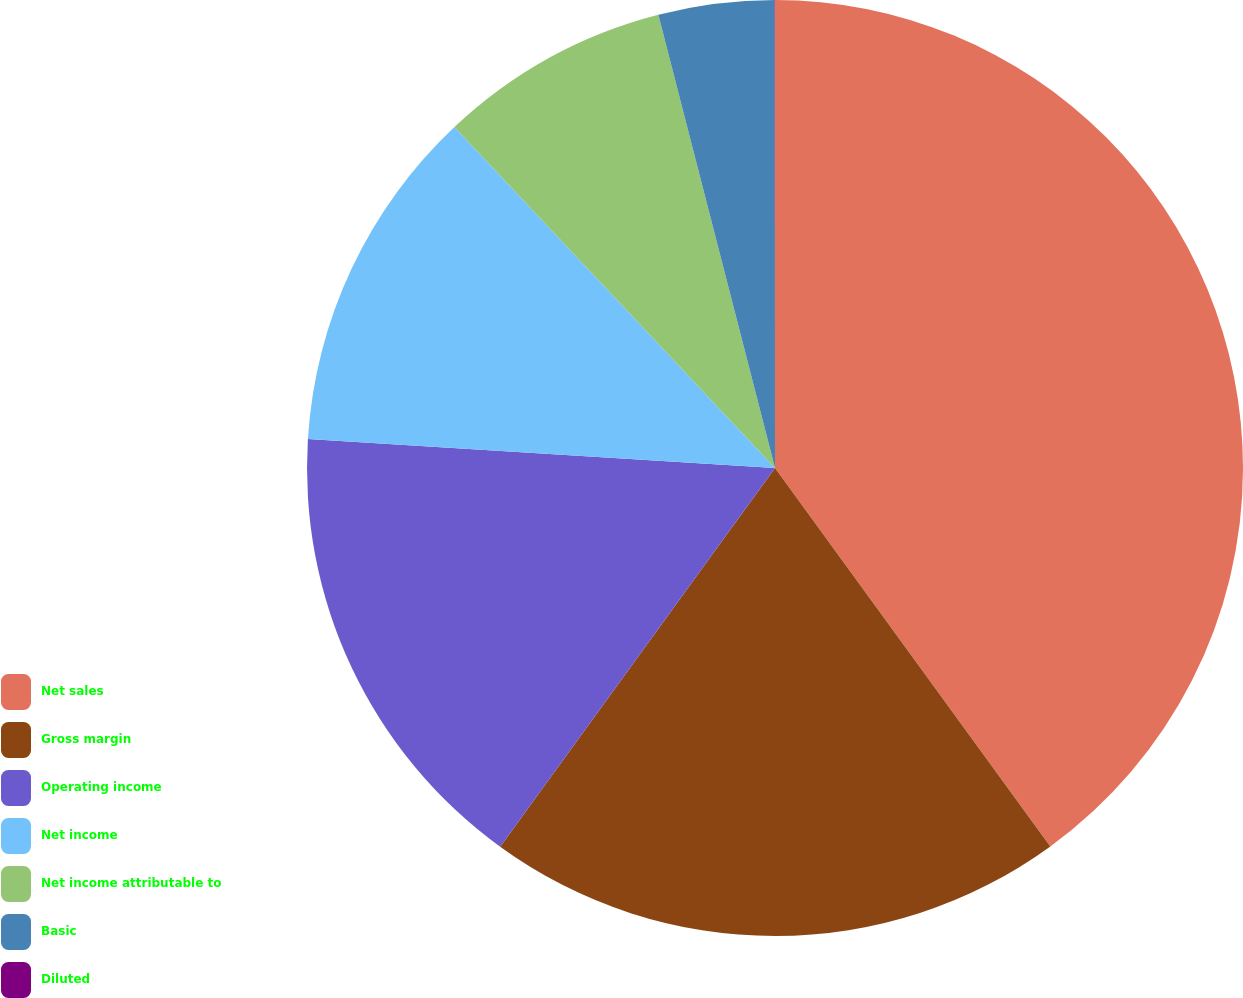Convert chart. <chart><loc_0><loc_0><loc_500><loc_500><pie_chart><fcel>Net sales<fcel>Gross margin<fcel>Operating income<fcel>Net income<fcel>Net income attributable to<fcel>Basic<fcel>Diluted<nl><fcel>39.99%<fcel>20.0%<fcel>16.0%<fcel>12.0%<fcel>8.0%<fcel>4.0%<fcel>0.01%<nl></chart> 